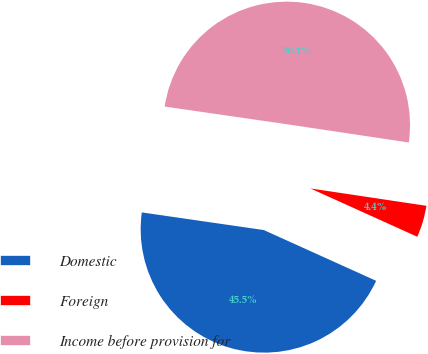Convert chart. <chart><loc_0><loc_0><loc_500><loc_500><pie_chart><fcel>Domestic<fcel>Foreign<fcel>Income before provision for<nl><fcel>45.53%<fcel>4.39%<fcel>50.08%<nl></chart> 